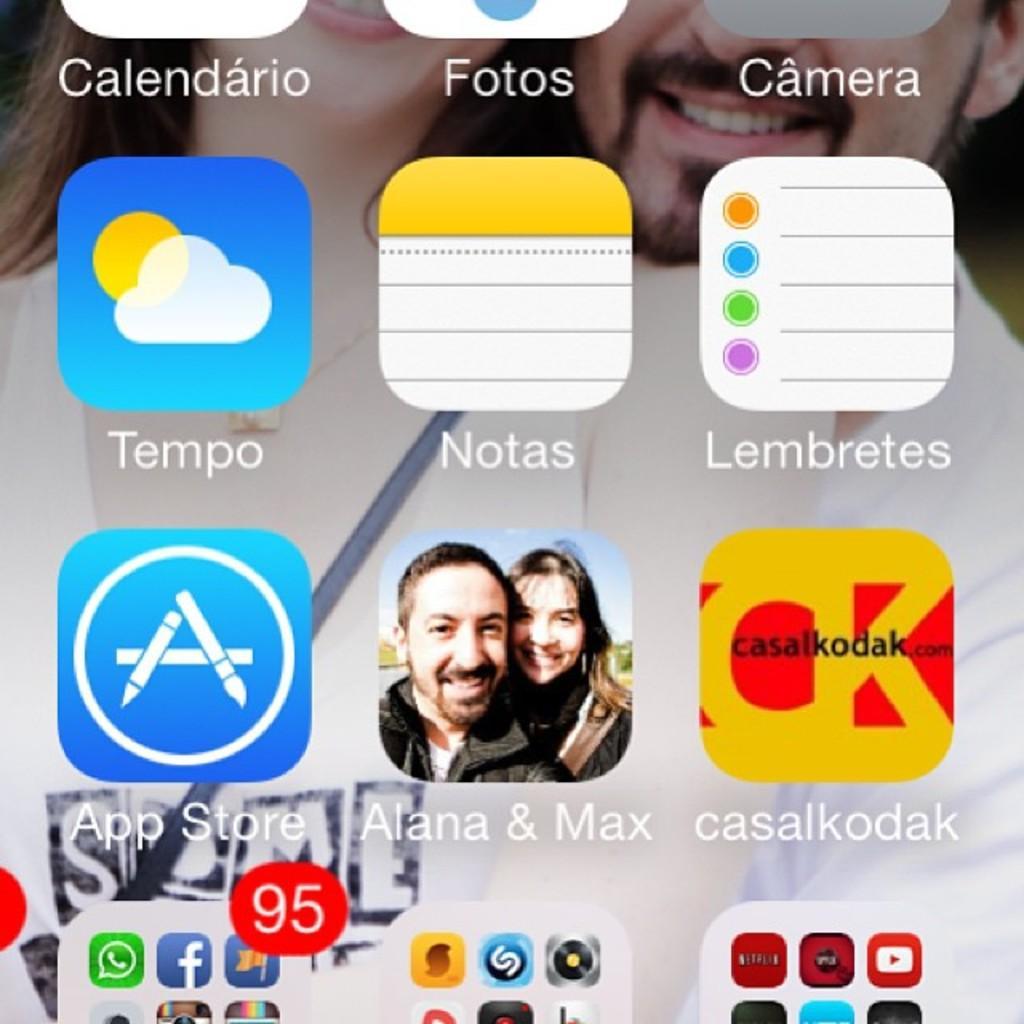Describe this image in one or two sentences. In this image we can see icons on the screen. 